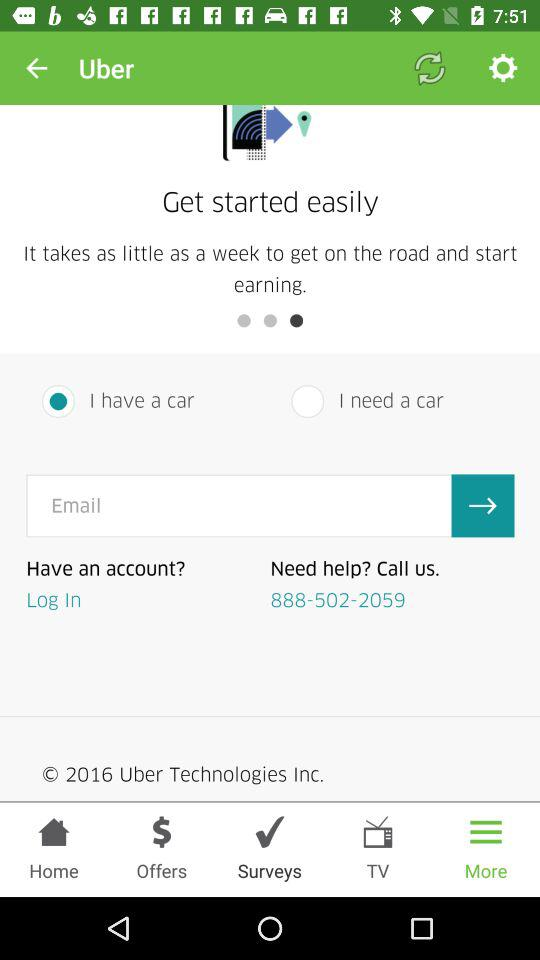Which option has been selected in bottom bar? The selected option is "More". 